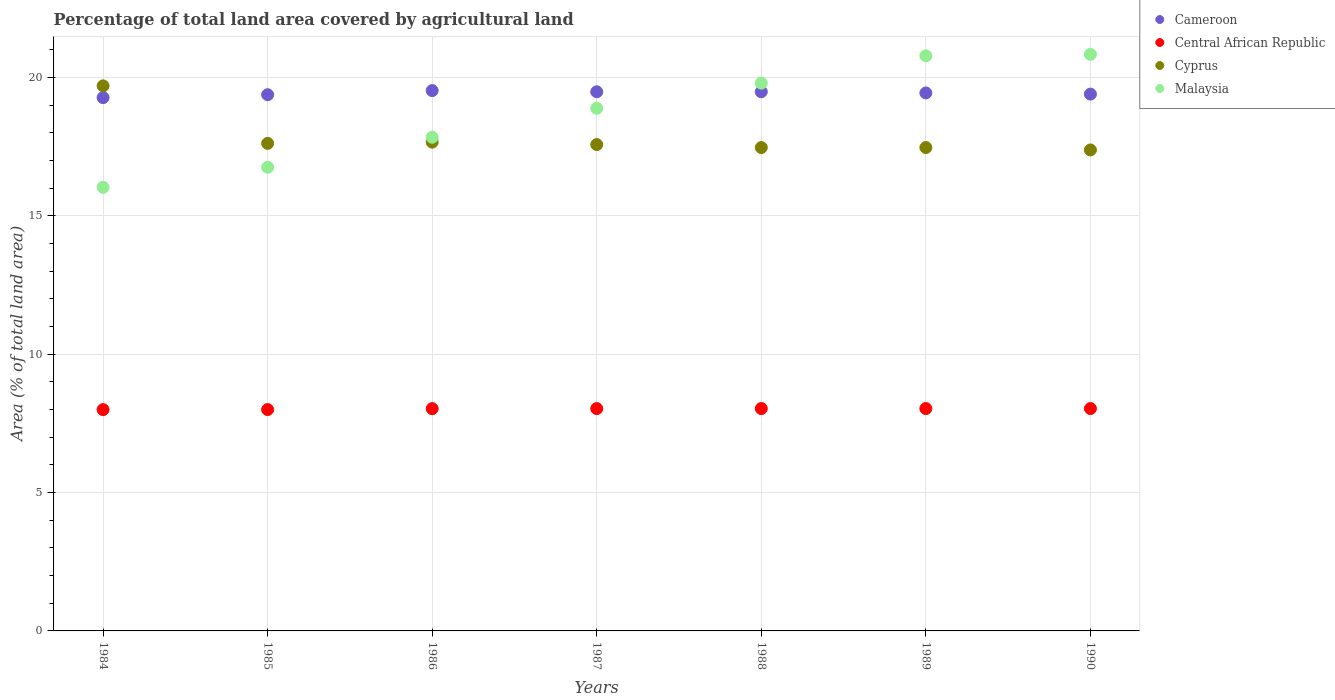What is the percentage of agricultural land in Cyprus in 1984?
Give a very brief answer. 19.7. Across all years, what is the maximum percentage of agricultural land in Malaysia?
Offer a very short reply. 20.84. Across all years, what is the minimum percentage of agricultural land in Cameroon?
Give a very brief answer. 19.27. In which year was the percentage of agricultural land in Central African Republic maximum?
Keep it short and to the point. 1988. In which year was the percentage of agricultural land in Central African Republic minimum?
Provide a succinct answer. 1984. What is the total percentage of agricultural land in Central African Republic in the graph?
Your answer should be compact. 56.17. What is the difference between the percentage of agricultural land in Malaysia in 1986 and that in 1989?
Your response must be concise. -2.94. What is the difference between the percentage of agricultural land in Malaysia in 1985 and the percentage of agricultural land in Cyprus in 1989?
Your answer should be compact. -0.71. What is the average percentage of agricultural land in Cyprus per year?
Provide a succinct answer. 17.84. In the year 1990, what is the difference between the percentage of agricultural land in Cameroon and percentage of agricultural land in Central African Republic?
Give a very brief answer. 11.36. What is the ratio of the percentage of agricultural land in Cyprus in 1985 to that in 1986?
Keep it short and to the point. 1. Is the difference between the percentage of agricultural land in Cameroon in 1985 and 1987 greater than the difference between the percentage of agricultural land in Central African Republic in 1985 and 1987?
Give a very brief answer. No. What is the difference between the highest and the second highest percentage of agricultural land in Malaysia?
Make the answer very short. 0.05. What is the difference between the highest and the lowest percentage of agricultural land in Central African Republic?
Provide a short and direct response. 0.04. In how many years, is the percentage of agricultural land in Cyprus greater than the average percentage of agricultural land in Cyprus taken over all years?
Offer a terse response. 1. Does the percentage of agricultural land in Cameroon monotonically increase over the years?
Your answer should be compact. No. Is the percentage of agricultural land in Central African Republic strictly greater than the percentage of agricultural land in Cyprus over the years?
Make the answer very short. No. Does the graph contain grids?
Your response must be concise. Yes. How many legend labels are there?
Offer a very short reply. 4. How are the legend labels stacked?
Your answer should be compact. Vertical. What is the title of the graph?
Give a very brief answer. Percentage of total land area covered by agricultural land. Does "France" appear as one of the legend labels in the graph?
Provide a short and direct response. No. What is the label or title of the X-axis?
Offer a terse response. Years. What is the label or title of the Y-axis?
Your response must be concise. Area (% of total land area). What is the Area (% of total land area) in Cameroon in 1984?
Provide a succinct answer. 19.27. What is the Area (% of total land area) of Central African Republic in 1984?
Provide a short and direct response. 8. What is the Area (% of total land area) in Cyprus in 1984?
Provide a short and direct response. 19.7. What is the Area (% of total land area) of Malaysia in 1984?
Offer a terse response. 16.03. What is the Area (% of total land area) in Cameroon in 1985?
Your response must be concise. 19.38. What is the Area (% of total land area) in Central African Republic in 1985?
Provide a short and direct response. 8. What is the Area (% of total land area) of Cyprus in 1985?
Your answer should be compact. 17.62. What is the Area (% of total land area) of Malaysia in 1985?
Offer a very short reply. 16.76. What is the Area (% of total land area) of Cameroon in 1986?
Offer a very short reply. 19.53. What is the Area (% of total land area) in Central African Republic in 1986?
Provide a succinct answer. 8.03. What is the Area (% of total land area) of Cyprus in 1986?
Your answer should be compact. 17.66. What is the Area (% of total land area) in Malaysia in 1986?
Ensure brevity in your answer.  17.84. What is the Area (% of total land area) of Cameroon in 1987?
Keep it short and to the point. 19.48. What is the Area (% of total land area) in Central African Republic in 1987?
Provide a succinct answer. 8.03. What is the Area (% of total land area) in Cyprus in 1987?
Your answer should be very brief. 17.58. What is the Area (% of total land area) in Malaysia in 1987?
Give a very brief answer. 18.89. What is the Area (% of total land area) in Cameroon in 1988?
Your response must be concise. 19.48. What is the Area (% of total land area) of Central African Republic in 1988?
Your answer should be compact. 8.04. What is the Area (% of total land area) in Cyprus in 1988?
Keep it short and to the point. 17.47. What is the Area (% of total land area) in Malaysia in 1988?
Give a very brief answer. 19.8. What is the Area (% of total land area) of Cameroon in 1989?
Make the answer very short. 19.44. What is the Area (% of total land area) in Central African Republic in 1989?
Offer a very short reply. 8.04. What is the Area (% of total land area) of Cyprus in 1989?
Your answer should be very brief. 17.47. What is the Area (% of total land area) of Malaysia in 1989?
Make the answer very short. 20.78. What is the Area (% of total land area) in Cameroon in 1990?
Make the answer very short. 19.4. What is the Area (% of total land area) in Central African Republic in 1990?
Ensure brevity in your answer.  8.04. What is the Area (% of total land area) of Cyprus in 1990?
Your answer should be compact. 17.38. What is the Area (% of total land area) in Malaysia in 1990?
Provide a short and direct response. 20.84. Across all years, what is the maximum Area (% of total land area) in Cameroon?
Provide a short and direct response. 19.53. Across all years, what is the maximum Area (% of total land area) of Central African Republic?
Provide a short and direct response. 8.04. Across all years, what is the maximum Area (% of total land area) of Cyprus?
Your answer should be compact. 19.7. Across all years, what is the maximum Area (% of total land area) of Malaysia?
Your answer should be very brief. 20.84. Across all years, what is the minimum Area (% of total land area) in Cameroon?
Offer a very short reply. 19.27. Across all years, what is the minimum Area (% of total land area) in Central African Republic?
Give a very brief answer. 8. Across all years, what is the minimum Area (% of total land area) in Cyprus?
Provide a succinct answer. 17.38. Across all years, what is the minimum Area (% of total land area) in Malaysia?
Give a very brief answer. 16.03. What is the total Area (% of total land area) of Cameroon in the graph?
Your answer should be compact. 135.98. What is the total Area (% of total land area) of Central African Republic in the graph?
Ensure brevity in your answer.  56.17. What is the total Area (% of total land area) of Cyprus in the graph?
Provide a short and direct response. 124.87. What is the total Area (% of total land area) of Malaysia in the graph?
Ensure brevity in your answer.  130.93. What is the difference between the Area (% of total land area) in Cameroon in 1984 and that in 1985?
Give a very brief answer. -0.11. What is the difference between the Area (% of total land area) of Central African Republic in 1984 and that in 1985?
Provide a short and direct response. -0. What is the difference between the Area (% of total land area) of Cyprus in 1984 and that in 1985?
Ensure brevity in your answer.  2.08. What is the difference between the Area (% of total land area) of Malaysia in 1984 and that in 1985?
Offer a very short reply. -0.72. What is the difference between the Area (% of total land area) in Cameroon in 1984 and that in 1986?
Give a very brief answer. -0.25. What is the difference between the Area (% of total land area) of Central African Republic in 1984 and that in 1986?
Make the answer very short. -0.04. What is the difference between the Area (% of total land area) in Cyprus in 1984 and that in 1986?
Make the answer very short. 2.03. What is the difference between the Area (% of total land area) in Malaysia in 1984 and that in 1986?
Make the answer very short. -1.81. What is the difference between the Area (% of total land area) in Cameroon in 1984 and that in 1987?
Offer a very short reply. -0.21. What is the difference between the Area (% of total land area) in Central African Republic in 1984 and that in 1987?
Provide a succinct answer. -0.04. What is the difference between the Area (% of total land area) of Cyprus in 1984 and that in 1987?
Your response must be concise. 2.12. What is the difference between the Area (% of total land area) in Malaysia in 1984 and that in 1987?
Offer a terse response. -2.86. What is the difference between the Area (% of total land area) of Cameroon in 1984 and that in 1988?
Your answer should be very brief. -0.21. What is the difference between the Area (% of total land area) of Central African Republic in 1984 and that in 1988?
Provide a short and direct response. -0.04. What is the difference between the Area (% of total land area) in Cyprus in 1984 and that in 1988?
Your answer should be very brief. 2.23. What is the difference between the Area (% of total land area) in Malaysia in 1984 and that in 1988?
Make the answer very short. -3.77. What is the difference between the Area (% of total land area) of Cameroon in 1984 and that in 1989?
Your answer should be very brief. -0.17. What is the difference between the Area (% of total land area) in Central African Republic in 1984 and that in 1989?
Your response must be concise. -0.04. What is the difference between the Area (% of total land area) of Cyprus in 1984 and that in 1989?
Your answer should be very brief. 2.23. What is the difference between the Area (% of total land area) of Malaysia in 1984 and that in 1989?
Your answer should be compact. -4.75. What is the difference between the Area (% of total land area) in Cameroon in 1984 and that in 1990?
Provide a short and direct response. -0.13. What is the difference between the Area (% of total land area) in Central African Republic in 1984 and that in 1990?
Provide a short and direct response. -0.04. What is the difference between the Area (% of total land area) in Cyprus in 1984 and that in 1990?
Give a very brief answer. 2.32. What is the difference between the Area (% of total land area) in Malaysia in 1984 and that in 1990?
Offer a very short reply. -4.81. What is the difference between the Area (% of total land area) in Cameroon in 1985 and that in 1986?
Give a very brief answer. -0.15. What is the difference between the Area (% of total land area) in Central African Republic in 1985 and that in 1986?
Offer a very short reply. -0.03. What is the difference between the Area (% of total land area) in Cyprus in 1985 and that in 1986?
Your answer should be very brief. -0.04. What is the difference between the Area (% of total land area) in Malaysia in 1985 and that in 1986?
Your response must be concise. -1.08. What is the difference between the Area (% of total land area) of Cameroon in 1985 and that in 1987?
Your answer should be compact. -0.11. What is the difference between the Area (% of total land area) of Central African Republic in 1985 and that in 1987?
Your answer should be very brief. -0.04. What is the difference between the Area (% of total land area) of Cyprus in 1985 and that in 1987?
Give a very brief answer. 0.04. What is the difference between the Area (% of total land area) in Malaysia in 1985 and that in 1987?
Your answer should be compact. -2.13. What is the difference between the Area (% of total land area) of Cameroon in 1985 and that in 1988?
Your answer should be very brief. -0.11. What is the difference between the Area (% of total land area) of Central African Republic in 1985 and that in 1988?
Your answer should be compact. -0.04. What is the difference between the Area (% of total land area) of Cyprus in 1985 and that in 1988?
Offer a terse response. 0.15. What is the difference between the Area (% of total land area) in Malaysia in 1985 and that in 1988?
Your answer should be compact. -3.04. What is the difference between the Area (% of total land area) in Cameroon in 1985 and that in 1989?
Give a very brief answer. -0.06. What is the difference between the Area (% of total land area) in Central African Republic in 1985 and that in 1989?
Your answer should be compact. -0.04. What is the difference between the Area (% of total land area) of Cyprus in 1985 and that in 1989?
Your answer should be compact. 0.15. What is the difference between the Area (% of total land area) of Malaysia in 1985 and that in 1989?
Provide a short and direct response. -4.03. What is the difference between the Area (% of total land area) of Cameroon in 1985 and that in 1990?
Make the answer very short. -0.02. What is the difference between the Area (% of total land area) of Central African Republic in 1985 and that in 1990?
Ensure brevity in your answer.  -0.04. What is the difference between the Area (% of total land area) in Cyprus in 1985 and that in 1990?
Ensure brevity in your answer.  0.24. What is the difference between the Area (% of total land area) of Malaysia in 1985 and that in 1990?
Offer a terse response. -4.08. What is the difference between the Area (% of total land area) of Cameroon in 1986 and that in 1987?
Provide a short and direct response. 0.04. What is the difference between the Area (% of total land area) in Central African Republic in 1986 and that in 1987?
Your answer should be compact. -0. What is the difference between the Area (% of total land area) in Cyprus in 1986 and that in 1987?
Provide a short and direct response. 0.09. What is the difference between the Area (% of total land area) of Malaysia in 1986 and that in 1987?
Your answer should be compact. -1.05. What is the difference between the Area (% of total land area) of Cameroon in 1986 and that in 1988?
Make the answer very short. 0.04. What is the difference between the Area (% of total land area) in Central African Republic in 1986 and that in 1988?
Provide a succinct answer. -0. What is the difference between the Area (% of total land area) in Cyprus in 1986 and that in 1988?
Offer a very short reply. 0.19. What is the difference between the Area (% of total land area) in Malaysia in 1986 and that in 1988?
Offer a very short reply. -1.96. What is the difference between the Area (% of total land area) of Cameroon in 1986 and that in 1989?
Ensure brevity in your answer.  0.08. What is the difference between the Area (% of total land area) in Central African Republic in 1986 and that in 1989?
Your answer should be very brief. -0. What is the difference between the Area (% of total land area) of Cyprus in 1986 and that in 1989?
Make the answer very short. 0.19. What is the difference between the Area (% of total land area) of Malaysia in 1986 and that in 1989?
Make the answer very short. -2.94. What is the difference between the Area (% of total land area) of Cameroon in 1986 and that in 1990?
Give a very brief answer. 0.13. What is the difference between the Area (% of total land area) of Central African Republic in 1986 and that in 1990?
Your answer should be compact. -0. What is the difference between the Area (% of total land area) of Cyprus in 1986 and that in 1990?
Give a very brief answer. 0.28. What is the difference between the Area (% of total land area) in Malaysia in 1986 and that in 1990?
Offer a terse response. -3. What is the difference between the Area (% of total land area) of Central African Republic in 1987 and that in 1988?
Make the answer very short. -0. What is the difference between the Area (% of total land area) in Cyprus in 1987 and that in 1988?
Ensure brevity in your answer.  0.11. What is the difference between the Area (% of total land area) of Malaysia in 1987 and that in 1988?
Your response must be concise. -0.91. What is the difference between the Area (% of total land area) of Cameroon in 1987 and that in 1989?
Offer a terse response. 0.04. What is the difference between the Area (% of total land area) in Central African Republic in 1987 and that in 1989?
Your answer should be compact. -0. What is the difference between the Area (% of total land area) of Cyprus in 1987 and that in 1989?
Give a very brief answer. 0.11. What is the difference between the Area (% of total land area) of Malaysia in 1987 and that in 1989?
Offer a terse response. -1.9. What is the difference between the Area (% of total land area) of Cameroon in 1987 and that in 1990?
Your response must be concise. 0.08. What is the difference between the Area (% of total land area) of Central African Republic in 1987 and that in 1990?
Ensure brevity in your answer.  -0. What is the difference between the Area (% of total land area) of Cyprus in 1987 and that in 1990?
Keep it short and to the point. 0.19. What is the difference between the Area (% of total land area) of Malaysia in 1987 and that in 1990?
Make the answer very short. -1.95. What is the difference between the Area (% of total land area) in Cameroon in 1988 and that in 1989?
Your answer should be compact. 0.04. What is the difference between the Area (% of total land area) in Cyprus in 1988 and that in 1989?
Offer a very short reply. 0. What is the difference between the Area (% of total land area) of Malaysia in 1988 and that in 1989?
Ensure brevity in your answer.  -0.99. What is the difference between the Area (% of total land area) in Cameroon in 1988 and that in 1990?
Ensure brevity in your answer.  0.08. What is the difference between the Area (% of total land area) of Cyprus in 1988 and that in 1990?
Keep it short and to the point. 0.09. What is the difference between the Area (% of total land area) in Malaysia in 1988 and that in 1990?
Your answer should be compact. -1.04. What is the difference between the Area (% of total land area) of Cameroon in 1989 and that in 1990?
Your response must be concise. 0.04. What is the difference between the Area (% of total land area) in Central African Republic in 1989 and that in 1990?
Your answer should be compact. 0. What is the difference between the Area (% of total land area) of Cyprus in 1989 and that in 1990?
Keep it short and to the point. 0.09. What is the difference between the Area (% of total land area) in Malaysia in 1989 and that in 1990?
Provide a short and direct response. -0.05. What is the difference between the Area (% of total land area) of Cameroon in 1984 and the Area (% of total land area) of Central African Republic in 1985?
Offer a terse response. 11.27. What is the difference between the Area (% of total land area) in Cameroon in 1984 and the Area (% of total land area) in Cyprus in 1985?
Keep it short and to the point. 1.65. What is the difference between the Area (% of total land area) of Cameroon in 1984 and the Area (% of total land area) of Malaysia in 1985?
Give a very brief answer. 2.52. What is the difference between the Area (% of total land area) of Central African Republic in 1984 and the Area (% of total land area) of Cyprus in 1985?
Provide a succinct answer. -9.62. What is the difference between the Area (% of total land area) of Central African Republic in 1984 and the Area (% of total land area) of Malaysia in 1985?
Offer a terse response. -8.76. What is the difference between the Area (% of total land area) in Cyprus in 1984 and the Area (% of total land area) in Malaysia in 1985?
Your answer should be very brief. 2.94. What is the difference between the Area (% of total land area) of Cameroon in 1984 and the Area (% of total land area) of Central African Republic in 1986?
Make the answer very short. 11.24. What is the difference between the Area (% of total land area) in Cameroon in 1984 and the Area (% of total land area) in Cyprus in 1986?
Ensure brevity in your answer.  1.61. What is the difference between the Area (% of total land area) in Cameroon in 1984 and the Area (% of total land area) in Malaysia in 1986?
Your answer should be compact. 1.43. What is the difference between the Area (% of total land area) in Central African Republic in 1984 and the Area (% of total land area) in Cyprus in 1986?
Your answer should be very brief. -9.67. What is the difference between the Area (% of total land area) of Central African Republic in 1984 and the Area (% of total land area) of Malaysia in 1986?
Your answer should be very brief. -9.84. What is the difference between the Area (% of total land area) in Cyprus in 1984 and the Area (% of total land area) in Malaysia in 1986?
Your answer should be very brief. 1.86. What is the difference between the Area (% of total land area) in Cameroon in 1984 and the Area (% of total land area) in Central African Republic in 1987?
Provide a short and direct response. 11.24. What is the difference between the Area (% of total land area) of Cameroon in 1984 and the Area (% of total land area) of Cyprus in 1987?
Provide a short and direct response. 1.7. What is the difference between the Area (% of total land area) of Cameroon in 1984 and the Area (% of total land area) of Malaysia in 1987?
Your answer should be very brief. 0.39. What is the difference between the Area (% of total land area) in Central African Republic in 1984 and the Area (% of total land area) in Cyprus in 1987?
Provide a succinct answer. -9.58. What is the difference between the Area (% of total land area) in Central African Republic in 1984 and the Area (% of total land area) in Malaysia in 1987?
Keep it short and to the point. -10.89. What is the difference between the Area (% of total land area) of Cyprus in 1984 and the Area (% of total land area) of Malaysia in 1987?
Make the answer very short. 0.81. What is the difference between the Area (% of total land area) of Cameroon in 1984 and the Area (% of total land area) of Central African Republic in 1988?
Keep it short and to the point. 11.24. What is the difference between the Area (% of total land area) in Cameroon in 1984 and the Area (% of total land area) in Cyprus in 1988?
Your response must be concise. 1.8. What is the difference between the Area (% of total land area) of Cameroon in 1984 and the Area (% of total land area) of Malaysia in 1988?
Your answer should be very brief. -0.52. What is the difference between the Area (% of total land area) in Central African Republic in 1984 and the Area (% of total land area) in Cyprus in 1988?
Your answer should be very brief. -9.47. What is the difference between the Area (% of total land area) in Central African Republic in 1984 and the Area (% of total land area) in Malaysia in 1988?
Your answer should be compact. -11.8. What is the difference between the Area (% of total land area) of Cyprus in 1984 and the Area (% of total land area) of Malaysia in 1988?
Give a very brief answer. -0.1. What is the difference between the Area (% of total land area) of Cameroon in 1984 and the Area (% of total land area) of Central African Republic in 1989?
Your answer should be very brief. 11.24. What is the difference between the Area (% of total land area) of Cameroon in 1984 and the Area (% of total land area) of Cyprus in 1989?
Your response must be concise. 1.8. What is the difference between the Area (% of total land area) of Cameroon in 1984 and the Area (% of total land area) of Malaysia in 1989?
Ensure brevity in your answer.  -1.51. What is the difference between the Area (% of total land area) in Central African Republic in 1984 and the Area (% of total land area) in Cyprus in 1989?
Your answer should be compact. -9.47. What is the difference between the Area (% of total land area) in Central African Republic in 1984 and the Area (% of total land area) in Malaysia in 1989?
Provide a succinct answer. -12.79. What is the difference between the Area (% of total land area) in Cyprus in 1984 and the Area (% of total land area) in Malaysia in 1989?
Your response must be concise. -1.09. What is the difference between the Area (% of total land area) in Cameroon in 1984 and the Area (% of total land area) in Central African Republic in 1990?
Your answer should be very brief. 11.24. What is the difference between the Area (% of total land area) of Cameroon in 1984 and the Area (% of total land area) of Cyprus in 1990?
Provide a short and direct response. 1.89. What is the difference between the Area (% of total land area) in Cameroon in 1984 and the Area (% of total land area) in Malaysia in 1990?
Offer a terse response. -1.56. What is the difference between the Area (% of total land area) of Central African Republic in 1984 and the Area (% of total land area) of Cyprus in 1990?
Your response must be concise. -9.38. What is the difference between the Area (% of total land area) in Central African Republic in 1984 and the Area (% of total land area) in Malaysia in 1990?
Keep it short and to the point. -12.84. What is the difference between the Area (% of total land area) in Cyprus in 1984 and the Area (% of total land area) in Malaysia in 1990?
Ensure brevity in your answer.  -1.14. What is the difference between the Area (% of total land area) of Cameroon in 1985 and the Area (% of total land area) of Central African Republic in 1986?
Keep it short and to the point. 11.35. What is the difference between the Area (% of total land area) in Cameroon in 1985 and the Area (% of total land area) in Cyprus in 1986?
Your answer should be very brief. 1.72. What is the difference between the Area (% of total land area) of Cameroon in 1985 and the Area (% of total land area) of Malaysia in 1986?
Offer a very short reply. 1.54. What is the difference between the Area (% of total land area) in Central African Republic in 1985 and the Area (% of total land area) in Cyprus in 1986?
Your response must be concise. -9.66. What is the difference between the Area (% of total land area) of Central African Republic in 1985 and the Area (% of total land area) of Malaysia in 1986?
Your response must be concise. -9.84. What is the difference between the Area (% of total land area) in Cyprus in 1985 and the Area (% of total land area) in Malaysia in 1986?
Your answer should be very brief. -0.22. What is the difference between the Area (% of total land area) in Cameroon in 1985 and the Area (% of total land area) in Central African Republic in 1987?
Your answer should be very brief. 11.34. What is the difference between the Area (% of total land area) of Cameroon in 1985 and the Area (% of total land area) of Cyprus in 1987?
Give a very brief answer. 1.8. What is the difference between the Area (% of total land area) in Cameroon in 1985 and the Area (% of total land area) in Malaysia in 1987?
Keep it short and to the point. 0.49. What is the difference between the Area (% of total land area) of Central African Republic in 1985 and the Area (% of total land area) of Cyprus in 1987?
Provide a short and direct response. -9.58. What is the difference between the Area (% of total land area) in Central African Republic in 1985 and the Area (% of total land area) in Malaysia in 1987?
Your response must be concise. -10.89. What is the difference between the Area (% of total land area) of Cyprus in 1985 and the Area (% of total land area) of Malaysia in 1987?
Your answer should be very brief. -1.27. What is the difference between the Area (% of total land area) in Cameroon in 1985 and the Area (% of total land area) in Central African Republic in 1988?
Your answer should be compact. 11.34. What is the difference between the Area (% of total land area) in Cameroon in 1985 and the Area (% of total land area) in Cyprus in 1988?
Ensure brevity in your answer.  1.91. What is the difference between the Area (% of total land area) of Cameroon in 1985 and the Area (% of total land area) of Malaysia in 1988?
Your answer should be very brief. -0.42. What is the difference between the Area (% of total land area) in Central African Republic in 1985 and the Area (% of total land area) in Cyprus in 1988?
Offer a terse response. -9.47. What is the difference between the Area (% of total land area) of Central African Republic in 1985 and the Area (% of total land area) of Malaysia in 1988?
Your response must be concise. -11.8. What is the difference between the Area (% of total land area) in Cyprus in 1985 and the Area (% of total land area) in Malaysia in 1988?
Make the answer very short. -2.18. What is the difference between the Area (% of total land area) in Cameroon in 1985 and the Area (% of total land area) in Central African Republic in 1989?
Keep it short and to the point. 11.34. What is the difference between the Area (% of total land area) of Cameroon in 1985 and the Area (% of total land area) of Cyprus in 1989?
Provide a short and direct response. 1.91. What is the difference between the Area (% of total land area) in Cameroon in 1985 and the Area (% of total land area) in Malaysia in 1989?
Keep it short and to the point. -1.4. What is the difference between the Area (% of total land area) of Central African Republic in 1985 and the Area (% of total land area) of Cyprus in 1989?
Your answer should be compact. -9.47. What is the difference between the Area (% of total land area) of Central African Republic in 1985 and the Area (% of total land area) of Malaysia in 1989?
Offer a terse response. -12.78. What is the difference between the Area (% of total land area) in Cyprus in 1985 and the Area (% of total land area) in Malaysia in 1989?
Offer a very short reply. -3.16. What is the difference between the Area (% of total land area) of Cameroon in 1985 and the Area (% of total land area) of Central African Republic in 1990?
Your response must be concise. 11.34. What is the difference between the Area (% of total land area) of Cameroon in 1985 and the Area (% of total land area) of Cyprus in 1990?
Offer a terse response. 2. What is the difference between the Area (% of total land area) in Cameroon in 1985 and the Area (% of total land area) in Malaysia in 1990?
Offer a very short reply. -1.46. What is the difference between the Area (% of total land area) in Central African Republic in 1985 and the Area (% of total land area) in Cyprus in 1990?
Your response must be concise. -9.38. What is the difference between the Area (% of total land area) in Central African Republic in 1985 and the Area (% of total land area) in Malaysia in 1990?
Your answer should be compact. -12.84. What is the difference between the Area (% of total land area) of Cyprus in 1985 and the Area (% of total land area) of Malaysia in 1990?
Keep it short and to the point. -3.22. What is the difference between the Area (% of total land area) in Cameroon in 1986 and the Area (% of total land area) in Central African Republic in 1987?
Your response must be concise. 11.49. What is the difference between the Area (% of total land area) in Cameroon in 1986 and the Area (% of total land area) in Cyprus in 1987?
Ensure brevity in your answer.  1.95. What is the difference between the Area (% of total land area) of Cameroon in 1986 and the Area (% of total land area) of Malaysia in 1987?
Ensure brevity in your answer.  0.64. What is the difference between the Area (% of total land area) in Central African Republic in 1986 and the Area (% of total land area) in Cyprus in 1987?
Make the answer very short. -9.54. What is the difference between the Area (% of total land area) of Central African Republic in 1986 and the Area (% of total land area) of Malaysia in 1987?
Keep it short and to the point. -10.85. What is the difference between the Area (% of total land area) of Cyprus in 1986 and the Area (% of total land area) of Malaysia in 1987?
Offer a very short reply. -1.22. What is the difference between the Area (% of total land area) in Cameroon in 1986 and the Area (% of total land area) in Central African Republic in 1988?
Offer a terse response. 11.49. What is the difference between the Area (% of total land area) of Cameroon in 1986 and the Area (% of total land area) of Cyprus in 1988?
Provide a succinct answer. 2.06. What is the difference between the Area (% of total land area) of Cameroon in 1986 and the Area (% of total land area) of Malaysia in 1988?
Your response must be concise. -0.27. What is the difference between the Area (% of total land area) in Central African Republic in 1986 and the Area (% of total land area) in Cyprus in 1988?
Offer a very short reply. -9.44. What is the difference between the Area (% of total land area) in Central African Republic in 1986 and the Area (% of total land area) in Malaysia in 1988?
Your answer should be very brief. -11.76. What is the difference between the Area (% of total land area) of Cyprus in 1986 and the Area (% of total land area) of Malaysia in 1988?
Offer a terse response. -2.13. What is the difference between the Area (% of total land area) of Cameroon in 1986 and the Area (% of total land area) of Central African Republic in 1989?
Provide a succinct answer. 11.49. What is the difference between the Area (% of total land area) of Cameroon in 1986 and the Area (% of total land area) of Cyprus in 1989?
Your response must be concise. 2.06. What is the difference between the Area (% of total land area) in Cameroon in 1986 and the Area (% of total land area) in Malaysia in 1989?
Keep it short and to the point. -1.26. What is the difference between the Area (% of total land area) of Central African Republic in 1986 and the Area (% of total land area) of Cyprus in 1989?
Provide a short and direct response. -9.44. What is the difference between the Area (% of total land area) in Central African Republic in 1986 and the Area (% of total land area) in Malaysia in 1989?
Your response must be concise. -12.75. What is the difference between the Area (% of total land area) of Cyprus in 1986 and the Area (% of total land area) of Malaysia in 1989?
Give a very brief answer. -3.12. What is the difference between the Area (% of total land area) of Cameroon in 1986 and the Area (% of total land area) of Central African Republic in 1990?
Ensure brevity in your answer.  11.49. What is the difference between the Area (% of total land area) of Cameroon in 1986 and the Area (% of total land area) of Cyprus in 1990?
Your answer should be very brief. 2.14. What is the difference between the Area (% of total land area) of Cameroon in 1986 and the Area (% of total land area) of Malaysia in 1990?
Make the answer very short. -1.31. What is the difference between the Area (% of total land area) of Central African Republic in 1986 and the Area (% of total land area) of Cyprus in 1990?
Offer a terse response. -9.35. What is the difference between the Area (% of total land area) in Central African Republic in 1986 and the Area (% of total land area) in Malaysia in 1990?
Your answer should be very brief. -12.8. What is the difference between the Area (% of total land area) of Cyprus in 1986 and the Area (% of total land area) of Malaysia in 1990?
Offer a very short reply. -3.17. What is the difference between the Area (% of total land area) in Cameroon in 1987 and the Area (% of total land area) in Central African Republic in 1988?
Provide a succinct answer. 11.45. What is the difference between the Area (% of total land area) of Cameroon in 1987 and the Area (% of total land area) of Cyprus in 1988?
Provide a short and direct response. 2.02. What is the difference between the Area (% of total land area) of Cameroon in 1987 and the Area (% of total land area) of Malaysia in 1988?
Your answer should be compact. -0.31. What is the difference between the Area (% of total land area) in Central African Republic in 1987 and the Area (% of total land area) in Cyprus in 1988?
Provide a short and direct response. -9.43. What is the difference between the Area (% of total land area) in Central African Republic in 1987 and the Area (% of total land area) in Malaysia in 1988?
Your response must be concise. -11.76. What is the difference between the Area (% of total land area) in Cyprus in 1987 and the Area (% of total land area) in Malaysia in 1988?
Offer a very short reply. -2.22. What is the difference between the Area (% of total land area) of Cameroon in 1987 and the Area (% of total land area) of Central African Republic in 1989?
Make the answer very short. 11.45. What is the difference between the Area (% of total land area) in Cameroon in 1987 and the Area (% of total land area) in Cyprus in 1989?
Ensure brevity in your answer.  2.02. What is the difference between the Area (% of total land area) in Cameroon in 1987 and the Area (% of total land area) in Malaysia in 1989?
Make the answer very short. -1.3. What is the difference between the Area (% of total land area) in Central African Republic in 1987 and the Area (% of total land area) in Cyprus in 1989?
Your answer should be very brief. -9.43. What is the difference between the Area (% of total land area) of Central African Republic in 1987 and the Area (% of total land area) of Malaysia in 1989?
Your response must be concise. -12.75. What is the difference between the Area (% of total land area) of Cyprus in 1987 and the Area (% of total land area) of Malaysia in 1989?
Offer a terse response. -3.21. What is the difference between the Area (% of total land area) of Cameroon in 1987 and the Area (% of total land area) of Central African Republic in 1990?
Make the answer very short. 11.45. What is the difference between the Area (% of total land area) of Cameroon in 1987 and the Area (% of total land area) of Cyprus in 1990?
Offer a very short reply. 2.1. What is the difference between the Area (% of total land area) in Cameroon in 1987 and the Area (% of total land area) in Malaysia in 1990?
Your response must be concise. -1.35. What is the difference between the Area (% of total land area) in Central African Republic in 1987 and the Area (% of total land area) in Cyprus in 1990?
Your answer should be compact. -9.35. What is the difference between the Area (% of total land area) of Central African Republic in 1987 and the Area (% of total land area) of Malaysia in 1990?
Give a very brief answer. -12.8. What is the difference between the Area (% of total land area) of Cyprus in 1987 and the Area (% of total land area) of Malaysia in 1990?
Offer a terse response. -3.26. What is the difference between the Area (% of total land area) in Cameroon in 1988 and the Area (% of total land area) in Central African Republic in 1989?
Your answer should be very brief. 11.45. What is the difference between the Area (% of total land area) in Cameroon in 1988 and the Area (% of total land area) in Cyprus in 1989?
Your response must be concise. 2.02. What is the difference between the Area (% of total land area) in Cameroon in 1988 and the Area (% of total land area) in Malaysia in 1989?
Your answer should be compact. -1.3. What is the difference between the Area (% of total land area) of Central African Republic in 1988 and the Area (% of total land area) of Cyprus in 1989?
Give a very brief answer. -9.43. What is the difference between the Area (% of total land area) in Central African Republic in 1988 and the Area (% of total land area) in Malaysia in 1989?
Your response must be concise. -12.75. What is the difference between the Area (% of total land area) in Cyprus in 1988 and the Area (% of total land area) in Malaysia in 1989?
Provide a short and direct response. -3.31. What is the difference between the Area (% of total land area) in Cameroon in 1988 and the Area (% of total land area) in Central African Republic in 1990?
Ensure brevity in your answer.  11.45. What is the difference between the Area (% of total land area) of Cameroon in 1988 and the Area (% of total land area) of Cyprus in 1990?
Ensure brevity in your answer.  2.1. What is the difference between the Area (% of total land area) of Cameroon in 1988 and the Area (% of total land area) of Malaysia in 1990?
Give a very brief answer. -1.35. What is the difference between the Area (% of total land area) of Central African Republic in 1988 and the Area (% of total land area) of Cyprus in 1990?
Provide a short and direct response. -9.35. What is the difference between the Area (% of total land area) of Central African Republic in 1988 and the Area (% of total land area) of Malaysia in 1990?
Your answer should be very brief. -12.8. What is the difference between the Area (% of total land area) in Cyprus in 1988 and the Area (% of total land area) in Malaysia in 1990?
Ensure brevity in your answer.  -3.37. What is the difference between the Area (% of total land area) in Cameroon in 1989 and the Area (% of total land area) in Central African Republic in 1990?
Offer a very short reply. 11.41. What is the difference between the Area (% of total land area) of Cameroon in 1989 and the Area (% of total land area) of Cyprus in 1990?
Your response must be concise. 2.06. What is the difference between the Area (% of total land area) in Cameroon in 1989 and the Area (% of total land area) in Malaysia in 1990?
Provide a short and direct response. -1.4. What is the difference between the Area (% of total land area) in Central African Republic in 1989 and the Area (% of total land area) in Cyprus in 1990?
Provide a succinct answer. -9.35. What is the difference between the Area (% of total land area) in Central African Republic in 1989 and the Area (% of total land area) in Malaysia in 1990?
Your answer should be compact. -12.8. What is the difference between the Area (% of total land area) in Cyprus in 1989 and the Area (% of total land area) in Malaysia in 1990?
Your answer should be very brief. -3.37. What is the average Area (% of total land area) in Cameroon per year?
Offer a very short reply. 19.43. What is the average Area (% of total land area) of Central African Republic per year?
Your response must be concise. 8.02. What is the average Area (% of total land area) in Cyprus per year?
Ensure brevity in your answer.  17.84. What is the average Area (% of total land area) of Malaysia per year?
Your response must be concise. 18.7. In the year 1984, what is the difference between the Area (% of total land area) in Cameroon and Area (% of total land area) in Central African Republic?
Provide a short and direct response. 11.27. In the year 1984, what is the difference between the Area (% of total land area) in Cameroon and Area (% of total land area) in Cyprus?
Keep it short and to the point. -0.43. In the year 1984, what is the difference between the Area (% of total land area) in Cameroon and Area (% of total land area) in Malaysia?
Offer a terse response. 3.24. In the year 1984, what is the difference between the Area (% of total land area) of Central African Republic and Area (% of total land area) of Cyprus?
Provide a succinct answer. -11.7. In the year 1984, what is the difference between the Area (% of total land area) in Central African Republic and Area (% of total land area) in Malaysia?
Your response must be concise. -8.03. In the year 1984, what is the difference between the Area (% of total land area) of Cyprus and Area (% of total land area) of Malaysia?
Provide a succinct answer. 3.67. In the year 1985, what is the difference between the Area (% of total land area) of Cameroon and Area (% of total land area) of Central African Republic?
Keep it short and to the point. 11.38. In the year 1985, what is the difference between the Area (% of total land area) in Cameroon and Area (% of total land area) in Cyprus?
Your answer should be very brief. 1.76. In the year 1985, what is the difference between the Area (% of total land area) in Cameroon and Area (% of total land area) in Malaysia?
Offer a very short reply. 2.62. In the year 1985, what is the difference between the Area (% of total land area) of Central African Republic and Area (% of total land area) of Cyprus?
Provide a short and direct response. -9.62. In the year 1985, what is the difference between the Area (% of total land area) in Central African Republic and Area (% of total land area) in Malaysia?
Offer a terse response. -8.76. In the year 1985, what is the difference between the Area (% of total land area) of Cyprus and Area (% of total land area) of Malaysia?
Ensure brevity in your answer.  0.86. In the year 1986, what is the difference between the Area (% of total land area) of Cameroon and Area (% of total land area) of Central African Republic?
Your response must be concise. 11.49. In the year 1986, what is the difference between the Area (% of total land area) of Cameroon and Area (% of total land area) of Cyprus?
Provide a succinct answer. 1.86. In the year 1986, what is the difference between the Area (% of total land area) in Cameroon and Area (% of total land area) in Malaysia?
Keep it short and to the point. 1.69. In the year 1986, what is the difference between the Area (% of total land area) of Central African Republic and Area (% of total land area) of Cyprus?
Give a very brief answer. -9.63. In the year 1986, what is the difference between the Area (% of total land area) of Central African Republic and Area (% of total land area) of Malaysia?
Your answer should be compact. -9.81. In the year 1986, what is the difference between the Area (% of total land area) of Cyprus and Area (% of total land area) of Malaysia?
Your response must be concise. -0.18. In the year 1987, what is the difference between the Area (% of total land area) of Cameroon and Area (% of total land area) of Central African Republic?
Your response must be concise. 11.45. In the year 1987, what is the difference between the Area (% of total land area) in Cameroon and Area (% of total land area) in Cyprus?
Offer a very short reply. 1.91. In the year 1987, what is the difference between the Area (% of total land area) of Cameroon and Area (% of total land area) of Malaysia?
Offer a very short reply. 0.6. In the year 1987, what is the difference between the Area (% of total land area) of Central African Republic and Area (% of total land area) of Cyprus?
Make the answer very short. -9.54. In the year 1987, what is the difference between the Area (% of total land area) of Central African Republic and Area (% of total land area) of Malaysia?
Provide a succinct answer. -10.85. In the year 1987, what is the difference between the Area (% of total land area) of Cyprus and Area (% of total land area) of Malaysia?
Provide a succinct answer. -1.31. In the year 1988, what is the difference between the Area (% of total land area) in Cameroon and Area (% of total land area) in Central African Republic?
Your answer should be compact. 11.45. In the year 1988, what is the difference between the Area (% of total land area) of Cameroon and Area (% of total land area) of Cyprus?
Keep it short and to the point. 2.02. In the year 1988, what is the difference between the Area (% of total land area) in Cameroon and Area (% of total land area) in Malaysia?
Keep it short and to the point. -0.31. In the year 1988, what is the difference between the Area (% of total land area) of Central African Republic and Area (% of total land area) of Cyprus?
Ensure brevity in your answer.  -9.43. In the year 1988, what is the difference between the Area (% of total land area) in Central African Republic and Area (% of total land area) in Malaysia?
Provide a short and direct response. -11.76. In the year 1988, what is the difference between the Area (% of total land area) in Cyprus and Area (% of total land area) in Malaysia?
Your answer should be compact. -2.33. In the year 1989, what is the difference between the Area (% of total land area) in Cameroon and Area (% of total land area) in Central African Republic?
Ensure brevity in your answer.  11.41. In the year 1989, what is the difference between the Area (% of total land area) of Cameroon and Area (% of total land area) of Cyprus?
Keep it short and to the point. 1.97. In the year 1989, what is the difference between the Area (% of total land area) in Cameroon and Area (% of total land area) in Malaysia?
Offer a terse response. -1.34. In the year 1989, what is the difference between the Area (% of total land area) of Central African Republic and Area (% of total land area) of Cyprus?
Make the answer very short. -9.43. In the year 1989, what is the difference between the Area (% of total land area) of Central African Republic and Area (% of total land area) of Malaysia?
Your answer should be compact. -12.75. In the year 1989, what is the difference between the Area (% of total land area) in Cyprus and Area (% of total land area) in Malaysia?
Ensure brevity in your answer.  -3.31. In the year 1990, what is the difference between the Area (% of total land area) in Cameroon and Area (% of total land area) in Central African Republic?
Your response must be concise. 11.36. In the year 1990, what is the difference between the Area (% of total land area) in Cameroon and Area (% of total land area) in Cyprus?
Ensure brevity in your answer.  2.02. In the year 1990, what is the difference between the Area (% of total land area) in Cameroon and Area (% of total land area) in Malaysia?
Give a very brief answer. -1.44. In the year 1990, what is the difference between the Area (% of total land area) in Central African Republic and Area (% of total land area) in Cyprus?
Ensure brevity in your answer.  -9.35. In the year 1990, what is the difference between the Area (% of total land area) in Central African Republic and Area (% of total land area) in Malaysia?
Ensure brevity in your answer.  -12.8. In the year 1990, what is the difference between the Area (% of total land area) of Cyprus and Area (% of total land area) of Malaysia?
Make the answer very short. -3.46. What is the ratio of the Area (% of total land area) of Cameroon in 1984 to that in 1985?
Offer a very short reply. 0.99. What is the ratio of the Area (% of total land area) in Central African Republic in 1984 to that in 1985?
Keep it short and to the point. 1. What is the ratio of the Area (% of total land area) of Cyprus in 1984 to that in 1985?
Make the answer very short. 1.12. What is the ratio of the Area (% of total land area) in Malaysia in 1984 to that in 1985?
Make the answer very short. 0.96. What is the ratio of the Area (% of total land area) in Cameroon in 1984 to that in 1986?
Your answer should be compact. 0.99. What is the ratio of the Area (% of total land area) in Cyprus in 1984 to that in 1986?
Make the answer very short. 1.12. What is the ratio of the Area (% of total land area) of Malaysia in 1984 to that in 1986?
Provide a short and direct response. 0.9. What is the ratio of the Area (% of total land area) in Cameroon in 1984 to that in 1987?
Your answer should be compact. 0.99. What is the ratio of the Area (% of total land area) of Cyprus in 1984 to that in 1987?
Provide a short and direct response. 1.12. What is the ratio of the Area (% of total land area) in Malaysia in 1984 to that in 1987?
Give a very brief answer. 0.85. What is the ratio of the Area (% of total land area) in Cameroon in 1984 to that in 1988?
Keep it short and to the point. 0.99. What is the ratio of the Area (% of total land area) of Cyprus in 1984 to that in 1988?
Ensure brevity in your answer.  1.13. What is the ratio of the Area (% of total land area) of Malaysia in 1984 to that in 1988?
Your answer should be compact. 0.81. What is the ratio of the Area (% of total land area) of Cameroon in 1984 to that in 1989?
Give a very brief answer. 0.99. What is the ratio of the Area (% of total land area) of Central African Republic in 1984 to that in 1989?
Offer a very short reply. 1. What is the ratio of the Area (% of total land area) of Cyprus in 1984 to that in 1989?
Keep it short and to the point. 1.13. What is the ratio of the Area (% of total land area) of Malaysia in 1984 to that in 1989?
Offer a very short reply. 0.77. What is the ratio of the Area (% of total land area) of Cyprus in 1984 to that in 1990?
Keep it short and to the point. 1.13. What is the ratio of the Area (% of total land area) of Malaysia in 1984 to that in 1990?
Offer a terse response. 0.77. What is the ratio of the Area (% of total land area) of Cyprus in 1985 to that in 1986?
Keep it short and to the point. 1. What is the ratio of the Area (% of total land area) of Malaysia in 1985 to that in 1986?
Your answer should be very brief. 0.94. What is the ratio of the Area (% of total land area) of Cameroon in 1985 to that in 1987?
Your answer should be compact. 0.99. What is the ratio of the Area (% of total land area) of Cyprus in 1985 to that in 1987?
Give a very brief answer. 1. What is the ratio of the Area (% of total land area) in Malaysia in 1985 to that in 1987?
Provide a succinct answer. 0.89. What is the ratio of the Area (% of total land area) of Cyprus in 1985 to that in 1988?
Ensure brevity in your answer.  1.01. What is the ratio of the Area (% of total land area) in Malaysia in 1985 to that in 1988?
Offer a terse response. 0.85. What is the ratio of the Area (% of total land area) in Central African Republic in 1985 to that in 1989?
Offer a terse response. 1. What is the ratio of the Area (% of total land area) in Cyprus in 1985 to that in 1989?
Offer a terse response. 1.01. What is the ratio of the Area (% of total land area) in Malaysia in 1985 to that in 1989?
Provide a succinct answer. 0.81. What is the ratio of the Area (% of total land area) in Central African Republic in 1985 to that in 1990?
Your response must be concise. 1. What is the ratio of the Area (% of total land area) of Cyprus in 1985 to that in 1990?
Offer a very short reply. 1.01. What is the ratio of the Area (% of total land area) of Malaysia in 1985 to that in 1990?
Make the answer very short. 0.8. What is the ratio of the Area (% of total land area) in Central African Republic in 1986 to that in 1987?
Your answer should be compact. 1. What is the ratio of the Area (% of total land area) of Malaysia in 1986 to that in 1987?
Provide a short and direct response. 0.94. What is the ratio of the Area (% of total land area) in Cyprus in 1986 to that in 1988?
Offer a terse response. 1.01. What is the ratio of the Area (% of total land area) in Malaysia in 1986 to that in 1988?
Keep it short and to the point. 0.9. What is the ratio of the Area (% of total land area) in Central African Republic in 1986 to that in 1989?
Ensure brevity in your answer.  1. What is the ratio of the Area (% of total land area) in Cyprus in 1986 to that in 1989?
Provide a succinct answer. 1.01. What is the ratio of the Area (% of total land area) of Malaysia in 1986 to that in 1989?
Give a very brief answer. 0.86. What is the ratio of the Area (% of total land area) in Cyprus in 1986 to that in 1990?
Your response must be concise. 1.02. What is the ratio of the Area (% of total land area) in Malaysia in 1986 to that in 1990?
Make the answer very short. 0.86. What is the ratio of the Area (% of total land area) of Central African Republic in 1987 to that in 1988?
Your response must be concise. 1. What is the ratio of the Area (% of total land area) of Malaysia in 1987 to that in 1988?
Make the answer very short. 0.95. What is the ratio of the Area (% of total land area) of Central African Republic in 1987 to that in 1989?
Provide a succinct answer. 1. What is the ratio of the Area (% of total land area) of Cyprus in 1987 to that in 1989?
Ensure brevity in your answer.  1.01. What is the ratio of the Area (% of total land area) in Malaysia in 1987 to that in 1989?
Offer a terse response. 0.91. What is the ratio of the Area (% of total land area) in Cameroon in 1987 to that in 1990?
Make the answer very short. 1. What is the ratio of the Area (% of total land area) in Cyprus in 1987 to that in 1990?
Offer a terse response. 1.01. What is the ratio of the Area (% of total land area) in Malaysia in 1987 to that in 1990?
Your response must be concise. 0.91. What is the ratio of the Area (% of total land area) in Cameroon in 1988 to that in 1989?
Your answer should be compact. 1. What is the ratio of the Area (% of total land area) of Cyprus in 1988 to that in 1989?
Keep it short and to the point. 1. What is the ratio of the Area (% of total land area) in Malaysia in 1988 to that in 1989?
Your answer should be very brief. 0.95. What is the ratio of the Area (% of total land area) of Cameroon in 1988 to that in 1990?
Keep it short and to the point. 1. What is the ratio of the Area (% of total land area) of Malaysia in 1988 to that in 1990?
Keep it short and to the point. 0.95. What is the ratio of the Area (% of total land area) in Cameroon in 1989 to that in 1990?
Ensure brevity in your answer.  1. What is the ratio of the Area (% of total land area) in Cyprus in 1989 to that in 1990?
Give a very brief answer. 1. What is the difference between the highest and the second highest Area (% of total land area) in Cameroon?
Offer a terse response. 0.04. What is the difference between the highest and the second highest Area (% of total land area) in Cyprus?
Make the answer very short. 2.03. What is the difference between the highest and the second highest Area (% of total land area) in Malaysia?
Provide a short and direct response. 0.05. What is the difference between the highest and the lowest Area (% of total land area) of Cameroon?
Make the answer very short. 0.25. What is the difference between the highest and the lowest Area (% of total land area) of Central African Republic?
Your answer should be very brief. 0.04. What is the difference between the highest and the lowest Area (% of total land area) of Cyprus?
Ensure brevity in your answer.  2.32. What is the difference between the highest and the lowest Area (% of total land area) in Malaysia?
Give a very brief answer. 4.81. 